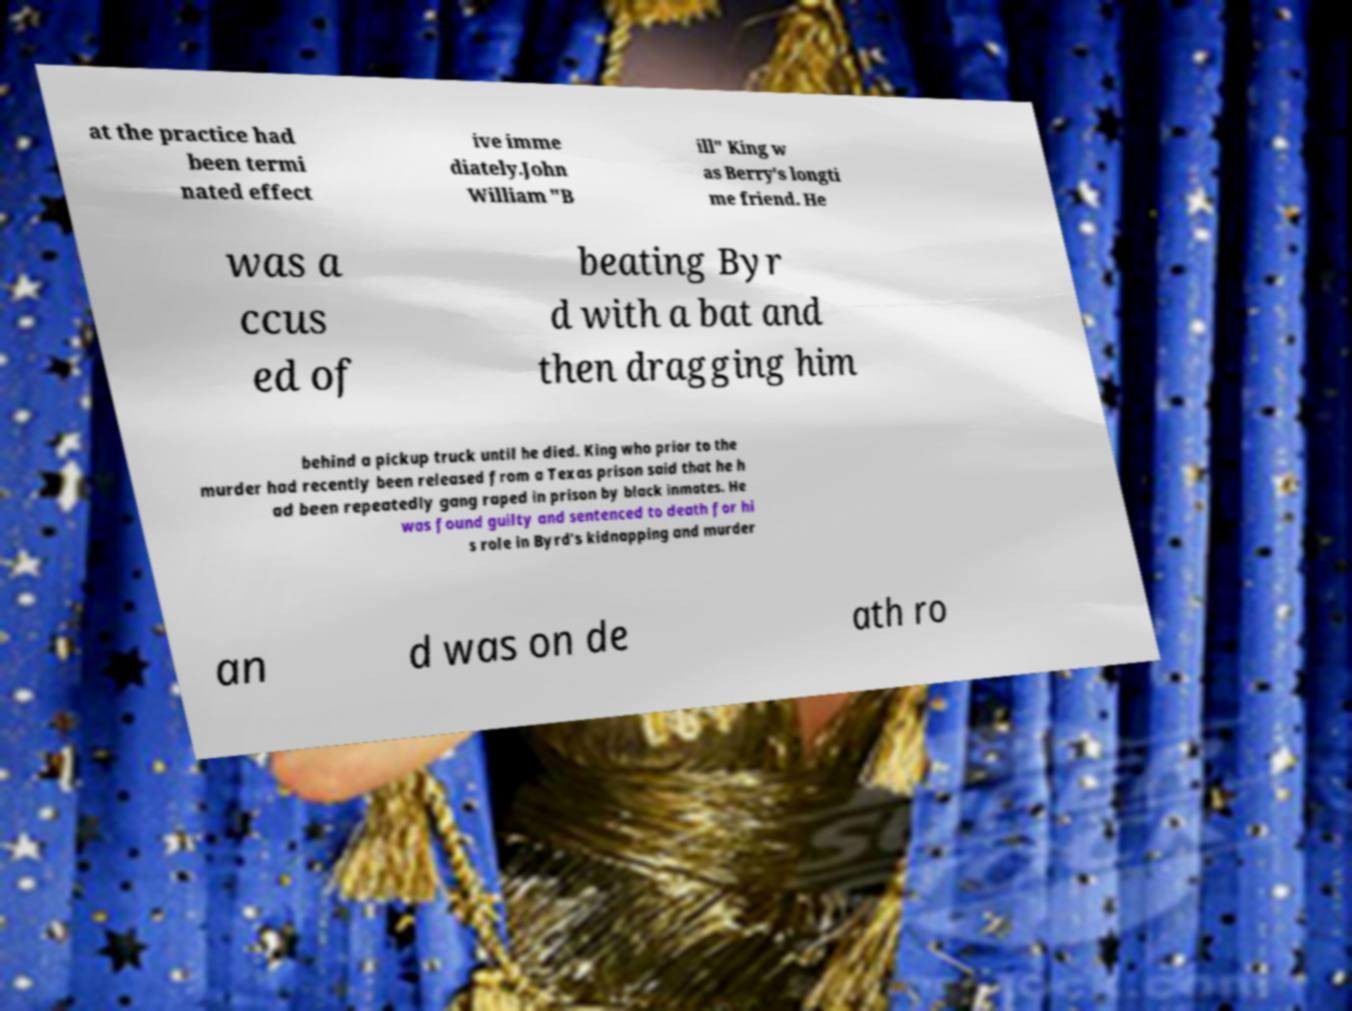There's text embedded in this image that I need extracted. Can you transcribe it verbatim? at the practice had been termi nated effect ive imme diately.John William "B ill" King w as Berry's longti me friend. He was a ccus ed of beating Byr d with a bat and then dragging him behind a pickup truck until he died. King who prior to the murder had recently been released from a Texas prison said that he h ad been repeatedly gang raped in prison by black inmates. He was found guilty and sentenced to death for hi s role in Byrd's kidnapping and murder an d was on de ath ro 